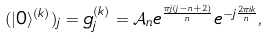<formula> <loc_0><loc_0><loc_500><loc_500>( | 0 \rangle ^ { ( k ) } ) _ { j } = g _ { j } ^ { ( k ) } = \mathcal { A } _ { n } e ^ { \frac { \pi j ( j - n + 2 ) } { n } } e ^ { - j \frac { 2 \pi i k } { n } } ,</formula> 